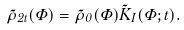Convert formula to latex. <formula><loc_0><loc_0><loc_500><loc_500>\tilde { \rho } _ { 2 t } ( { \Phi } ) = \tilde { \rho } _ { 0 } ( { \Phi } ) \tilde { K } _ { I } ( { \Phi } ; t ) .</formula> 